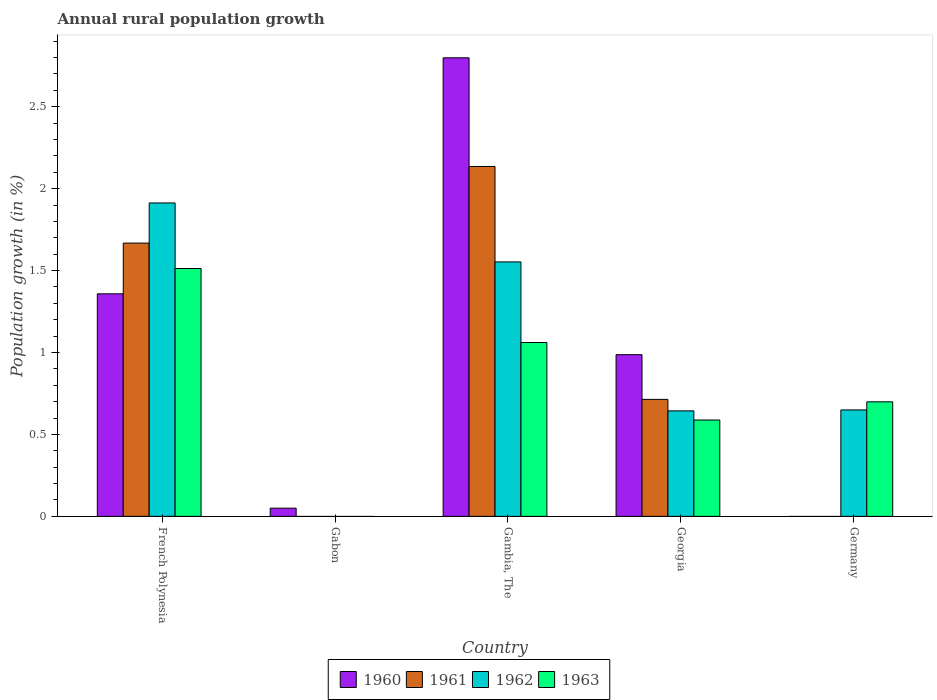How many different coloured bars are there?
Offer a very short reply. 4. Are the number of bars per tick equal to the number of legend labels?
Your answer should be very brief. No. Are the number of bars on each tick of the X-axis equal?
Your answer should be very brief. No. How many bars are there on the 4th tick from the left?
Keep it short and to the point. 4. What is the label of the 1st group of bars from the left?
Your response must be concise. French Polynesia. In how many cases, is the number of bars for a given country not equal to the number of legend labels?
Offer a very short reply. 2. What is the percentage of rural population growth in 1961 in Gambia, The?
Give a very brief answer. 2.14. Across all countries, what is the maximum percentage of rural population growth in 1961?
Provide a succinct answer. 2.14. Across all countries, what is the minimum percentage of rural population growth in 1963?
Your answer should be very brief. 0. In which country was the percentage of rural population growth in 1962 maximum?
Provide a succinct answer. French Polynesia. What is the total percentage of rural population growth in 1961 in the graph?
Ensure brevity in your answer.  4.52. What is the difference between the percentage of rural population growth in 1962 in French Polynesia and that in Germany?
Provide a short and direct response. 1.26. What is the difference between the percentage of rural population growth in 1961 in Georgia and the percentage of rural population growth in 1962 in Gambia, The?
Your response must be concise. -0.84. What is the average percentage of rural population growth in 1963 per country?
Provide a short and direct response. 0.77. What is the difference between the percentage of rural population growth of/in 1961 and percentage of rural population growth of/in 1963 in Gambia, The?
Provide a succinct answer. 1.07. In how many countries, is the percentage of rural population growth in 1960 greater than 0.4 %?
Provide a short and direct response. 3. What is the ratio of the percentage of rural population growth in 1962 in French Polynesia to that in Germany?
Your answer should be very brief. 2.94. Is the percentage of rural population growth in 1960 in Gabon less than that in Gambia, The?
Provide a succinct answer. Yes. Is the difference between the percentage of rural population growth in 1961 in Gambia, The and Georgia greater than the difference between the percentage of rural population growth in 1963 in Gambia, The and Georgia?
Offer a very short reply. Yes. What is the difference between the highest and the second highest percentage of rural population growth in 1962?
Offer a terse response. -1.26. What is the difference between the highest and the lowest percentage of rural population growth in 1963?
Your answer should be very brief. 1.51. Is it the case that in every country, the sum of the percentage of rural population growth in 1960 and percentage of rural population growth in 1963 is greater than the percentage of rural population growth in 1962?
Your response must be concise. Yes. How many countries are there in the graph?
Make the answer very short. 5. Are the values on the major ticks of Y-axis written in scientific E-notation?
Your response must be concise. No. Where does the legend appear in the graph?
Ensure brevity in your answer.  Bottom center. How are the legend labels stacked?
Your answer should be compact. Horizontal. What is the title of the graph?
Provide a short and direct response. Annual rural population growth. Does "2013" appear as one of the legend labels in the graph?
Your answer should be very brief. No. What is the label or title of the Y-axis?
Provide a short and direct response. Population growth (in %). What is the Population growth (in %) of 1960 in French Polynesia?
Offer a very short reply. 1.36. What is the Population growth (in %) in 1961 in French Polynesia?
Your response must be concise. 1.67. What is the Population growth (in %) in 1962 in French Polynesia?
Make the answer very short. 1.91. What is the Population growth (in %) of 1963 in French Polynesia?
Provide a short and direct response. 1.51. What is the Population growth (in %) in 1960 in Gabon?
Give a very brief answer. 0.05. What is the Population growth (in %) of 1960 in Gambia, The?
Give a very brief answer. 2.8. What is the Population growth (in %) of 1961 in Gambia, The?
Give a very brief answer. 2.14. What is the Population growth (in %) of 1962 in Gambia, The?
Your answer should be compact. 1.55. What is the Population growth (in %) in 1963 in Gambia, The?
Your answer should be compact. 1.06. What is the Population growth (in %) of 1960 in Georgia?
Your answer should be very brief. 0.99. What is the Population growth (in %) in 1961 in Georgia?
Keep it short and to the point. 0.71. What is the Population growth (in %) of 1962 in Georgia?
Ensure brevity in your answer.  0.64. What is the Population growth (in %) of 1963 in Georgia?
Your answer should be compact. 0.59. What is the Population growth (in %) in 1960 in Germany?
Your response must be concise. 0. What is the Population growth (in %) in 1961 in Germany?
Give a very brief answer. 0. What is the Population growth (in %) in 1962 in Germany?
Provide a succinct answer. 0.65. What is the Population growth (in %) of 1963 in Germany?
Offer a very short reply. 0.7. Across all countries, what is the maximum Population growth (in %) of 1960?
Ensure brevity in your answer.  2.8. Across all countries, what is the maximum Population growth (in %) in 1961?
Offer a terse response. 2.14. Across all countries, what is the maximum Population growth (in %) of 1962?
Give a very brief answer. 1.91. Across all countries, what is the maximum Population growth (in %) in 1963?
Offer a very short reply. 1.51. Across all countries, what is the minimum Population growth (in %) in 1960?
Provide a succinct answer. 0. Across all countries, what is the minimum Population growth (in %) in 1961?
Make the answer very short. 0. Across all countries, what is the minimum Population growth (in %) of 1963?
Your answer should be compact. 0. What is the total Population growth (in %) of 1960 in the graph?
Provide a short and direct response. 5.19. What is the total Population growth (in %) in 1961 in the graph?
Your response must be concise. 4.52. What is the total Population growth (in %) in 1962 in the graph?
Ensure brevity in your answer.  4.76. What is the total Population growth (in %) of 1963 in the graph?
Ensure brevity in your answer.  3.86. What is the difference between the Population growth (in %) in 1960 in French Polynesia and that in Gabon?
Give a very brief answer. 1.31. What is the difference between the Population growth (in %) in 1960 in French Polynesia and that in Gambia, The?
Make the answer very short. -1.44. What is the difference between the Population growth (in %) of 1961 in French Polynesia and that in Gambia, The?
Make the answer very short. -0.47. What is the difference between the Population growth (in %) in 1962 in French Polynesia and that in Gambia, The?
Provide a succinct answer. 0.36. What is the difference between the Population growth (in %) in 1963 in French Polynesia and that in Gambia, The?
Your answer should be compact. 0.45. What is the difference between the Population growth (in %) in 1960 in French Polynesia and that in Georgia?
Offer a terse response. 0.37. What is the difference between the Population growth (in %) in 1961 in French Polynesia and that in Georgia?
Make the answer very short. 0.95. What is the difference between the Population growth (in %) in 1962 in French Polynesia and that in Georgia?
Your answer should be very brief. 1.27. What is the difference between the Population growth (in %) in 1963 in French Polynesia and that in Georgia?
Keep it short and to the point. 0.92. What is the difference between the Population growth (in %) of 1962 in French Polynesia and that in Germany?
Keep it short and to the point. 1.26. What is the difference between the Population growth (in %) of 1963 in French Polynesia and that in Germany?
Make the answer very short. 0.81. What is the difference between the Population growth (in %) of 1960 in Gabon and that in Gambia, The?
Ensure brevity in your answer.  -2.75. What is the difference between the Population growth (in %) in 1960 in Gabon and that in Georgia?
Provide a short and direct response. -0.94. What is the difference between the Population growth (in %) in 1960 in Gambia, The and that in Georgia?
Your response must be concise. 1.81. What is the difference between the Population growth (in %) of 1961 in Gambia, The and that in Georgia?
Make the answer very short. 1.42. What is the difference between the Population growth (in %) in 1963 in Gambia, The and that in Georgia?
Offer a terse response. 0.47. What is the difference between the Population growth (in %) in 1962 in Gambia, The and that in Germany?
Make the answer very short. 0.9. What is the difference between the Population growth (in %) of 1963 in Gambia, The and that in Germany?
Provide a succinct answer. 0.36. What is the difference between the Population growth (in %) of 1962 in Georgia and that in Germany?
Keep it short and to the point. -0.01. What is the difference between the Population growth (in %) in 1963 in Georgia and that in Germany?
Keep it short and to the point. -0.11. What is the difference between the Population growth (in %) of 1960 in French Polynesia and the Population growth (in %) of 1961 in Gambia, The?
Offer a very short reply. -0.78. What is the difference between the Population growth (in %) of 1960 in French Polynesia and the Population growth (in %) of 1962 in Gambia, The?
Ensure brevity in your answer.  -0.19. What is the difference between the Population growth (in %) of 1960 in French Polynesia and the Population growth (in %) of 1963 in Gambia, The?
Your answer should be compact. 0.3. What is the difference between the Population growth (in %) in 1961 in French Polynesia and the Population growth (in %) in 1962 in Gambia, The?
Your response must be concise. 0.12. What is the difference between the Population growth (in %) of 1961 in French Polynesia and the Population growth (in %) of 1963 in Gambia, The?
Offer a terse response. 0.61. What is the difference between the Population growth (in %) of 1962 in French Polynesia and the Population growth (in %) of 1963 in Gambia, The?
Your answer should be compact. 0.85. What is the difference between the Population growth (in %) in 1960 in French Polynesia and the Population growth (in %) in 1961 in Georgia?
Ensure brevity in your answer.  0.64. What is the difference between the Population growth (in %) in 1960 in French Polynesia and the Population growth (in %) in 1962 in Georgia?
Ensure brevity in your answer.  0.71. What is the difference between the Population growth (in %) in 1960 in French Polynesia and the Population growth (in %) in 1963 in Georgia?
Offer a very short reply. 0.77. What is the difference between the Population growth (in %) of 1961 in French Polynesia and the Population growth (in %) of 1962 in Georgia?
Your response must be concise. 1.02. What is the difference between the Population growth (in %) of 1961 in French Polynesia and the Population growth (in %) of 1963 in Georgia?
Offer a terse response. 1.08. What is the difference between the Population growth (in %) in 1962 in French Polynesia and the Population growth (in %) in 1963 in Georgia?
Make the answer very short. 1.32. What is the difference between the Population growth (in %) in 1960 in French Polynesia and the Population growth (in %) in 1962 in Germany?
Ensure brevity in your answer.  0.71. What is the difference between the Population growth (in %) of 1960 in French Polynesia and the Population growth (in %) of 1963 in Germany?
Give a very brief answer. 0.66. What is the difference between the Population growth (in %) of 1961 in French Polynesia and the Population growth (in %) of 1962 in Germany?
Make the answer very short. 1.02. What is the difference between the Population growth (in %) in 1961 in French Polynesia and the Population growth (in %) in 1963 in Germany?
Your response must be concise. 0.97. What is the difference between the Population growth (in %) in 1962 in French Polynesia and the Population growth (in %) in 1963 in Germany?
Offer a very short reply. 1.21. What is the difference between the Population growth (in %) in 1960 in Gabon and the Population growth (in %) in 1961 in Gambia, The?
Ensure brevity in your answer.  -2.09. What is the difference between the Population growth (in %) of 1960 in Gabon and the Population growth (in %) of 1962 in Gambia, The?
Keep it short and to the point. -1.5. What is the difference between the Population growth (in %) in 1960 in Gabon and the Population growth (in %) in 1963 in Gambia, The?
Give a very brief answer. -1.01. What is the difference between the Population growth (in %) of 1960 in Gabon and the Population growth (in %) of 1961 in Georgia?
Keep it short and to the point. -0.66. What is the difference between the Population growth (in %) in 1960 in Gabon and the Population growth (in %) in 1962 in Georgia?
Provide a succinct answer. -0.59. What is the difference between the Population growth (in %) of 1960 in Gabon and the Population growth (in %) of 1963 in Georgia?
Provide a succinct answer. -0.54. What is the difference between the Population growth (in %) of 1960 in Gabon and the Population growth (in %) of 1962 in Germany?
Your answer should be very brief. -0.6. What is the difference between the Population growth (in %) in 1960 in Gabon and the Population growth (in %) in 1963 in Germany?
Give a very brief answer. -0.65. What is the difference between the Population growth (in %) of 1960 in Gambia, The and the Population growth (in %) of 1961 in Georgia?
Ensure brevity in your answer.  2.08. What is the difference between the Population growth (in %) in 1960 in Gambia, The and the Population growth (in %) in 1962 in Georgia?
Keep it short and to the point. 2.15. What is the difference between the Population growth (in %) in 1960 in Gambia, The and the Population growth (in %) in 1963 in Georgia?
Make the answer very short. 2.21. What is the difference between the Population growth (in %) in 1961 in Gambia, The and the Population growth (in %) in 1962 in Georgia?
Offer a terse response. 1.49. What is the difference between the Population growth (in %) of 1961 in Gambia, The and the Population growth (in %) of 1963 in Georgia?
Give a very brief answer. 1.55. What is the difference between the Population growth (in %) of 1960 in Gambia, The and the Population growth (in %) of 1962 in Germany?
Offer a terse response. 2.15. What is the difference between the Population growth (in %) of 1960 in Gambia, The and the Population growth (in %) of 1963 in Germany?
Your response must be concise. 2.1. What is the difference between the Population growth (in %) in 1961 in Gambia, The and the Population growth (in %) in 1962 in Germany?
Your response must be concise. 1.49. What is the difference between the Population growth (in %) of 1961 in Gambia, The and the Population growth (in %) of 1963 in Germany?
Your answer should be very brief. 1.44. What is the difference between the Population growth (in %) in 1962 in Gambia, The and the Population growth (in %) in 1963 in Germany?
Keep it short and to the point. 0.85. What is the difference between the Population growth (in %) of 1960 in Georgia and the Population growth (in %) of 1962 in Germany?
Your answer should be compact. 0.34. What is the difference between the Population growth (in %) in 1960 in Georgia and the Population growth (in %) in 1963 in Germany?
Provide a short and direct response. 0.29. What is the difference between the Population growth (in %) in 1961 in Georgia and the Population growth (in %) in 1962 in Germany?
Make the answer very short. 0.06. What is the difference between the Population growth (in %) in 1961 in Georgia and the Population growth (in %) in 1963 in Germany?
Provide a succinct answer. 0.01. What is the difference between the Population growth (in %) of 1962 in Georgia and the Population growth (in %) of 1963 in Germany?
Give a very brief answer. -0.06. What is the average Population growth (in %) of 1960 per country?
Make the answer very short. 1.04. What is the average Population growth (in %) of 1961 per country?
Give a very brief answer. 0.9. What is the average Population growth (in %) of 1962 per country?
Your answer should be compact. 0.95. What is the average Population growth (in %) of 1963 per country?
Your answer should be compact. 0.77. What is the difference between the Population growth (in %) of 1960 and Population growth (in %) of 1961 in French Polynesia?
Provide a short and direct response. -0.31. What is the difference between the Population growth (in %) in 1960 and Population growth (in %) in 1962 in French Polynesia?
Your response must be concise. -0.55. What is the difference between the Population growth (in %) in 1960 and Population growth (in %) in 1963 in French Polynesia?
Your response must be concise. -0.15. What is the difference between the Population growth (in %) in 1961 and Population growth (in %) in 1962 in French Polynesia?
Ensure brevity in your answer.  -0.24. What is the difference between the Population growth (in %) in 1961 and Population growth (in %) in 1963 in French Polynesia?
Keep it short and to the point. 0.16. What is the difference between the Population growth (in %) of 1960 and Population growth (in %) of 1961 in Gambia, The?
Keep it short and to the point. 0.66. What is the difference between the Population growth (in %) of 1960 and Population growth (in %) of 1962 in Gambia, The?
Make the answer very short. 1.25. What is the difference between the Population growth (in %) in 1960 and Population growth (in %) in 1963 in Gambia, The?
Provide a succinct answer. 1.74. What is the difference between the Population growth (in %) of 1961 and Population growth (in %) of 1962 in Gambia, The?
Make the answer very short. 0.58. What is the difference between the Population growth (in %) of 1961 and Population growth (in %) of 1963 in Gambia, The?
Provide a succinct answer. 1.07. What is the difference between the Population growth (in %) in 1962 and Population growth (in %) in 1963 in Gambia, The?
Your answer should be compact. 0.49. What is the difference between the Population growth (in %) of 1960 and Population growth (in %) of 1961 in Georgia?
Your answer should be compact. 0.27. What is the difference between the Population growth (in %) in 1960 and Population growth (in %) in 1962 in Georgia?
Give a very brief answer. 0.34. What is the difference between the Population growth (in %) in 1960 and Population growth (in %) in 1963 in Georgia?
Ensure brevity in your answer.  0.4. What is the difference between the Population growth (in %) in 1961 and Population growth (in %) in 1962 in Georgia?
Provide a succinct answer. 0.07. What is the difference between the Population growth (in %) of 1961 and Population growth (in %) of 1963 in Georgia?
Offer a very short reply. 0.13. What is the difference between the Population growth (in %) in 1962 and Population growth (in %) in 1963 in Georgia?
Your answer should be compact. 0.06. What is the difference between the Population growth (in %) in 1962 and Population growth (in %) in 1963 in Germany?
Ensure brevity in your answer.  -0.05. What is the ratio of the Population growth (in %) of 1960 in French Polynesia to that in Gabon?
Your answer should be very brief. 27.18. What is the ratio of the Population growth (in %) in 1960 in French Polynesia to that in Gambia, The?
Ensure brevity in your answer.  0.49. What is the ratio of the Population growth (in %) in 1961 in French Polynesia to that in Gambia, The?
Give a very brief answer. 0.78. What is the ratio of the Population growth (in %) in 1962 in French Polynesia to that in Gambia, The?
Your answer should be very brief. 1.23. What is the ratio of the Population growth (in %) in 1963 in French Polynesia to that in Gambia, The?
Your answer should be compact. 1.43. What is the ratio of the Population growth (in %) in 1960 in French Polynesia to that in Georgia?
Your answer should be compact. 1.38. What is the ratio of the Population growth (in %) of 1961 in French Polynesia to that in Georgia?
Ensure brevity in your answer.  2.34. What is the ratio of the Population growth (in %) in 1962 in French Polynesia to that in Georgia?
Offer a terse response. 2.97. What is the ratio of the Population growth (in %) in 1963 in French Polynesia to that in Georgia?
Your answer should be very brief. 2.57. What is the ratio of the Population growth (in %) in 1962 in French Polynesia to that in Germany?
Ensure brevity in your answer.  2.94. What is the ratio of the Population growth (in %) in 1963 in French Polynesia to that in Germany?
Your response must be concise. 2.16. What is the ratio of the Population growth (in %) in 1960 in Gabon to that in Gambia, The?
Your response must be concise. 0.02. What is the ratio of the Population growth (in %) of 1960 in Gabon to that in Georgia?
Provide a short and direct response. 0.05. What is the ratio of the Population growth (in %) of 1960 in Gambia, The to that in Georgia?
Provide a short and direct response. 2.84. What is the ratio of the Population growth (in %) of 1961 in Gambia, The to that in Georgia?
Your response must be concise. 2.99. What is the ratio of the Population growth (in %) of 1962 in Gambia, The to that in Georgia?
Provide a succinct answer. 2.41. What is the ratio of the Population growth (in %) in 1963 in Gambia, The to that in Georgia?
Provide a short and direct response. 1.8. What is the ratio of the Population growth (in %) of 1962 in Gambia, The to that in Germany?
Offer a very short reply. 2.39. What is the ratio of the Population growth (in %) in 1963 in Gambia, The to that in Germany?
Your answer should be very brief. 1.52. What is the ratio of the Population growth (in %) in 1962 in Georgia to that in Germany?
Your response must be concise. 0.99. What is the ratio of the Population growth (in %) in 1963 in Georgia to that in Germany?
Offer a very short reply. 0.84. What is the difference between the highest and the second highest Population growth (in %) in 1960?
Your response must be concise. 1.44. What is the difference between the highest and the second highest Population growth (in %) in 1961?
Provide a succinct answer. 0.47. What is the difference between the highest and the second highest Population growth (in %) of 1962?
Offer a terse response. 0.36. What is the difference between the highest and the second highest Population growth (in %) in 1963?
Your answer should be compact. 0.45. What is the difference between the highest and the lowest Population growth (in %) in 1960?
Offer a very short reply. 2.8. What is the difference between the highest and the lowest Population growth (in %) of 1961?
Give a very brief answer. 2.14. What is the difference between the highest and the lowest Population growth (in %) of 1962?
Your answer should be compact. 1.91. What is the difference between the highest and the lowest Population growth (in %) of 1963?
Make the answer very short. 1.51. 